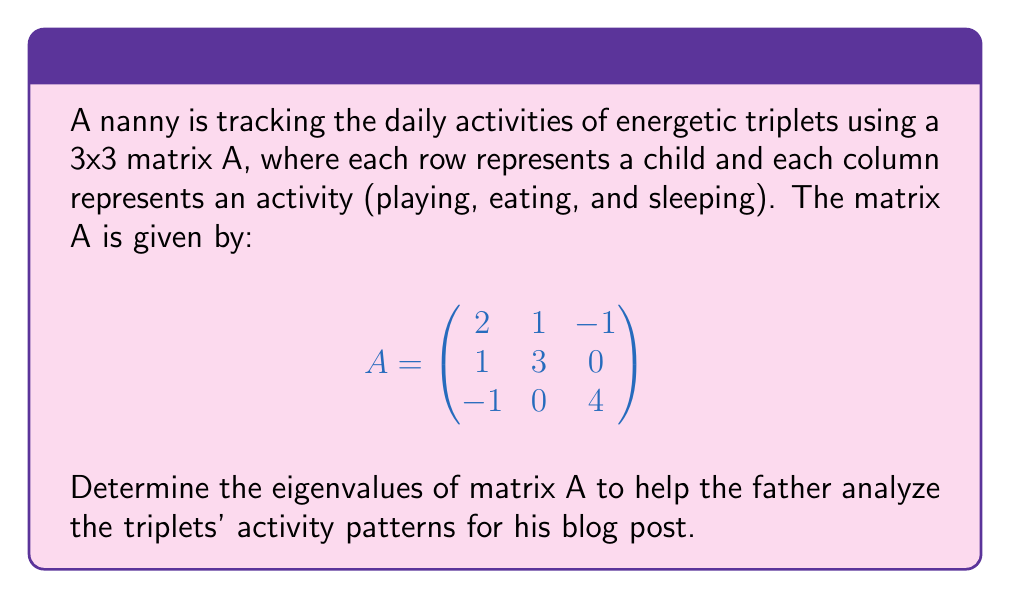Show me your answer to this math problem. To find the eigenvalues of matrix A, we need to solve the characteristic equation:

1) First, we write the characteristic equation:
   $det(A - \lambda I) = 0$

2) Expand the determinant:
   $$\begin{vmatrix}
   2-\lambda & 1 & -1 \\
   1 & 3-\lambda & 0 \\
   -1 & 0 & 4-\lambda
   \end{vmatrix} = 0$$

3) Calculate the determinant:
   $(2-\lambda)[(3-\lambda)(4-\lambda) - 0] + 1[1(4-\lambda) - (-1)(0)] + (-1)[1(0) - (-1)(3-\lambda)] = 0$

4) Simplify:
   $(2-\lambda)(12-7\lambda+\lambda^2) + 1(4-\lambda) + (3-\lambda) = 0$

5) Expand:
   $24-14\lambda+2\lambda^2-12\lambda+7\lambda^2-\lambda^3 + 4-\lambda + 3-\lambda = 0$

6) Collect terms:
   $-\lambda^3 + 9\lambda^2 - 17\lambda + 31 = 0$

7) This is the characteristic polynomial. To find its roots, we can use the rational root theorem or a computer algebra system. The roots are:

   $\lambda_1 = 1$
   $\lambda_2 = 3$
   $\lambda_3 = 5$

These are the eigenvalues of matrix A.
Answer: $\lambda_1 = 1$, $\lambda_2 = 3$, $\lambda_3 = 5$ 